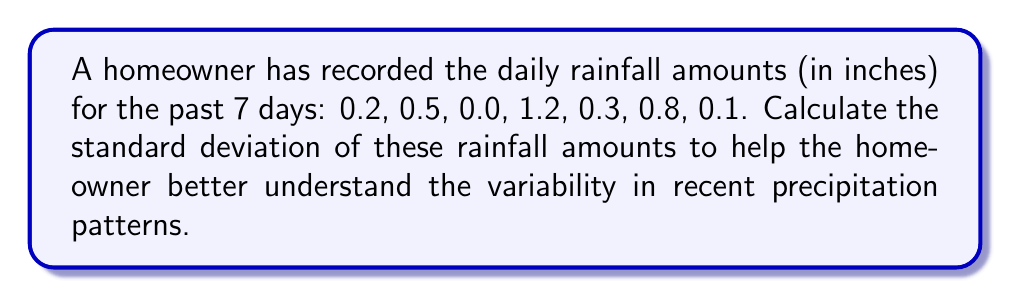Help me with this question. To calculate the standard deviation, we'll follow these steps:

1. Calculate the mean (average) rainfall:
   $$\bar{x} = \frac{0.2 + 0.5 + 0.0 + 1.2 + 0.3 + 0.8 + 0.1}{7} = \frac{3.1}{7} \approx 0.443$$

2. Calculate the squared differences from the mean:
   $$(0.2 - 0.443)^2 \approx 0.059$$
   $$(0.5 - 0.443)^2 \approx 0.003$$
   $$(0.0 - 0.443)^2 \approx 0.196$$
   $$(1.2 - 0.443)^2 \approx 0.574$$
   $$(0.3 - 0.443)^2 \approx 0.020$$
   $$(0.8 - 0.443)^2 \approx 0.128$$
   $$(0.1 - 0.443)^2 \approx 0.118$$

3. Sum the squared differences:
   $$0.059 + 0.003 + 0.196 + 0.574 + 0.020 + 0.128 + 0.118 = 1.098$$

4. Divide by (n-1) = 6 to get the variance:
   $$s^2 = \frac{1.098}{6} \approx 0.183$$

5. Take the square root to get the standard deviation:
   $$s = \sqrt{0.183} \approx 0.428$$
Answer: $0.428$ inches 